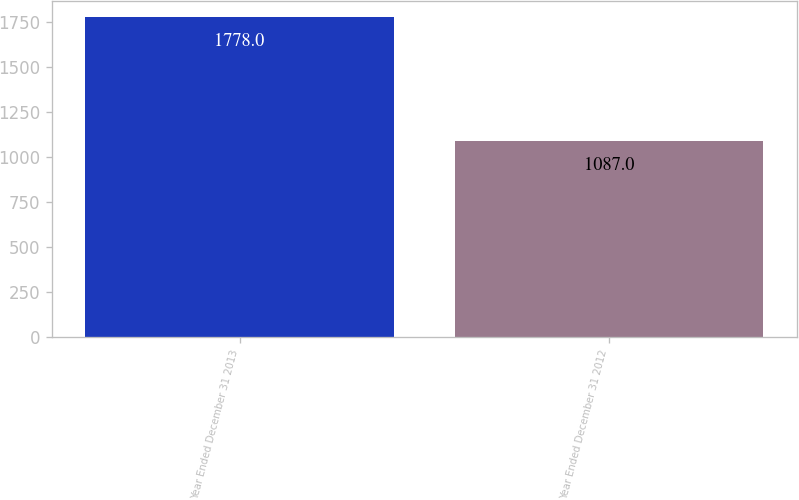<chart> <loc_0><loc_0><loc_500><loc_500><bar_chart><fcel>Year Ended December 31 2013<fcel>Year Ended December 31 2012<nl><fcel>1778<fcel>1087<nl></chart> 